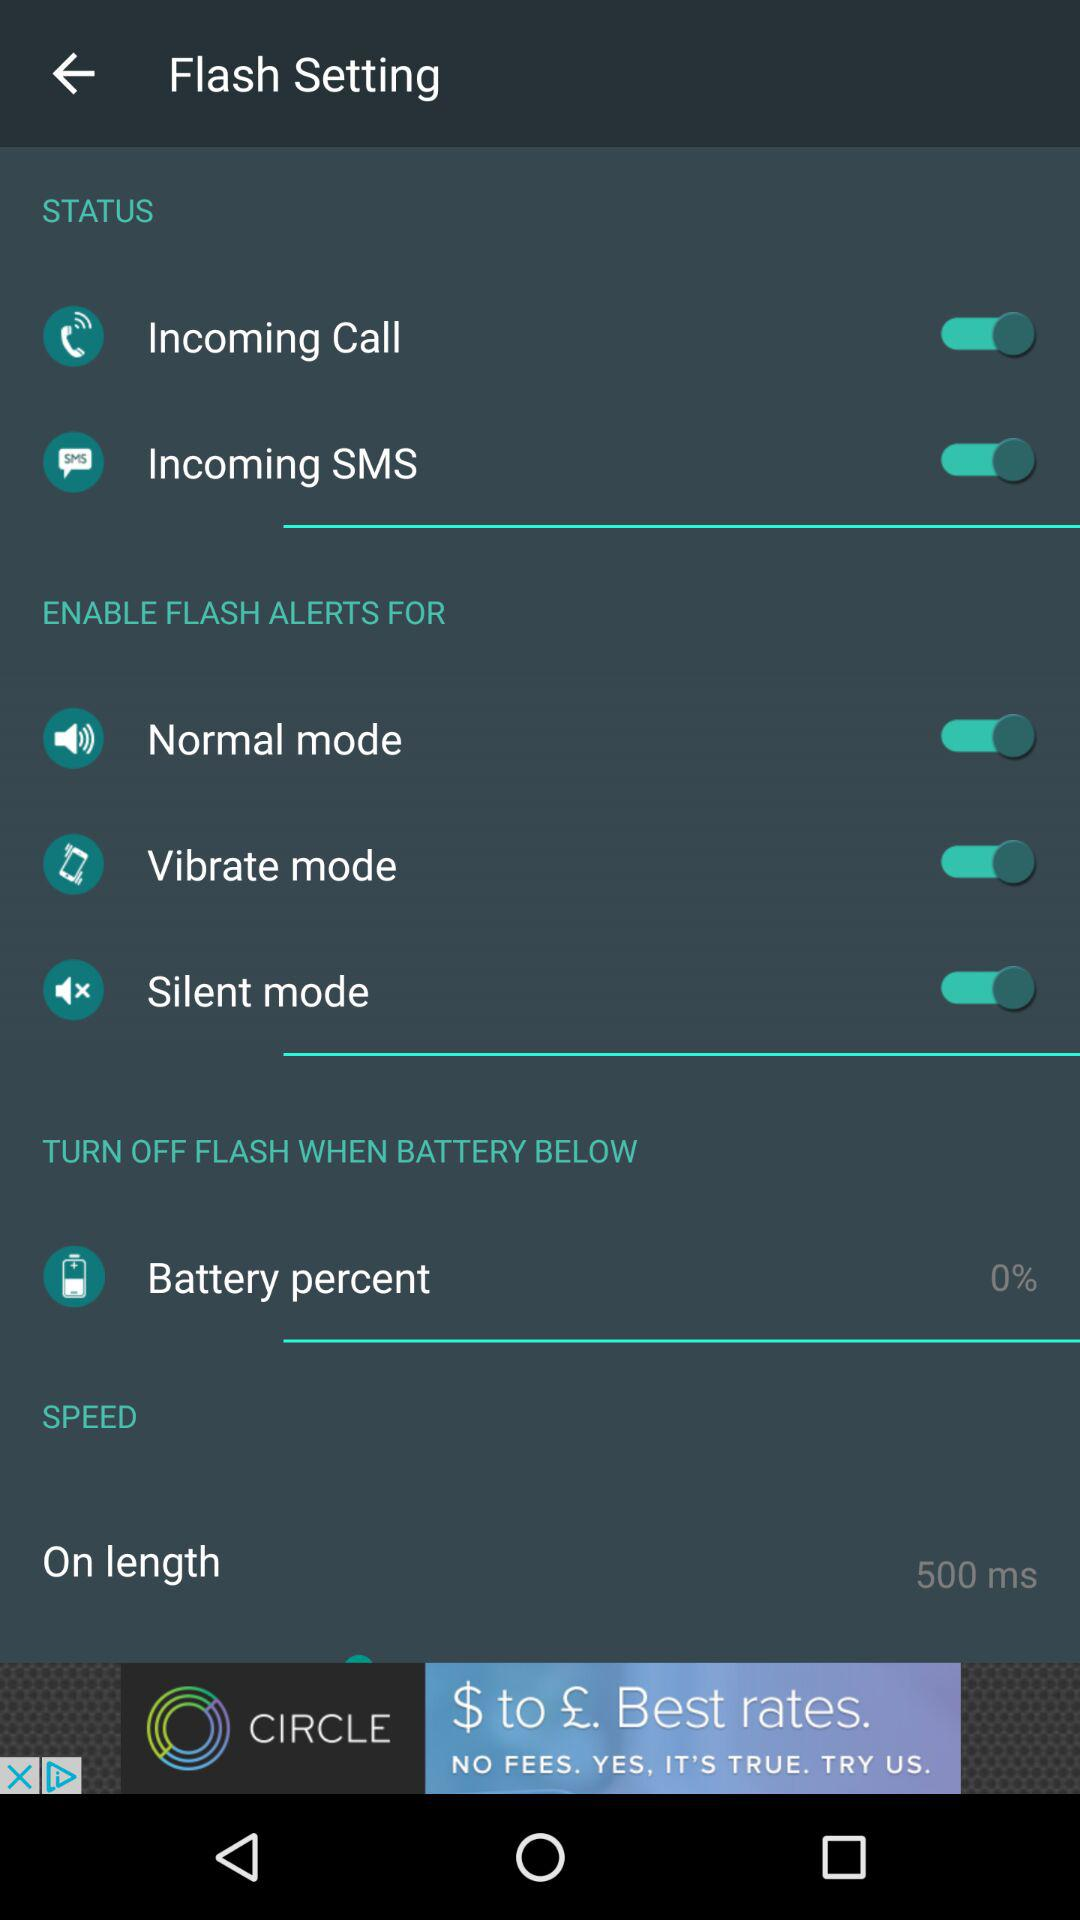What is the on length speed? The on length speed is 500 meters per second. 